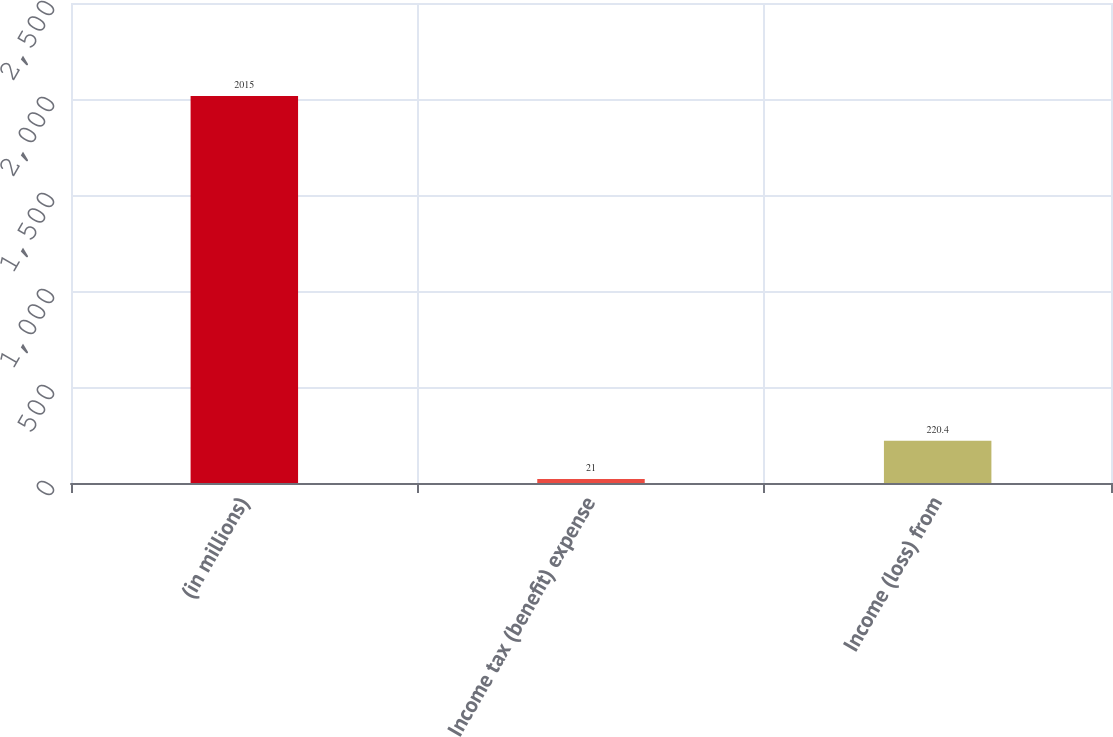Convert chart. <chart><loc_0><loc_0><loc_500><loc_500><bar_chart><fcel>(in millions)<fcel>Income tax (benefit) expense<fcel>Income (loss) from<nl><fcel>2015<fcel>21<fcel>220.4<nl></chart> 